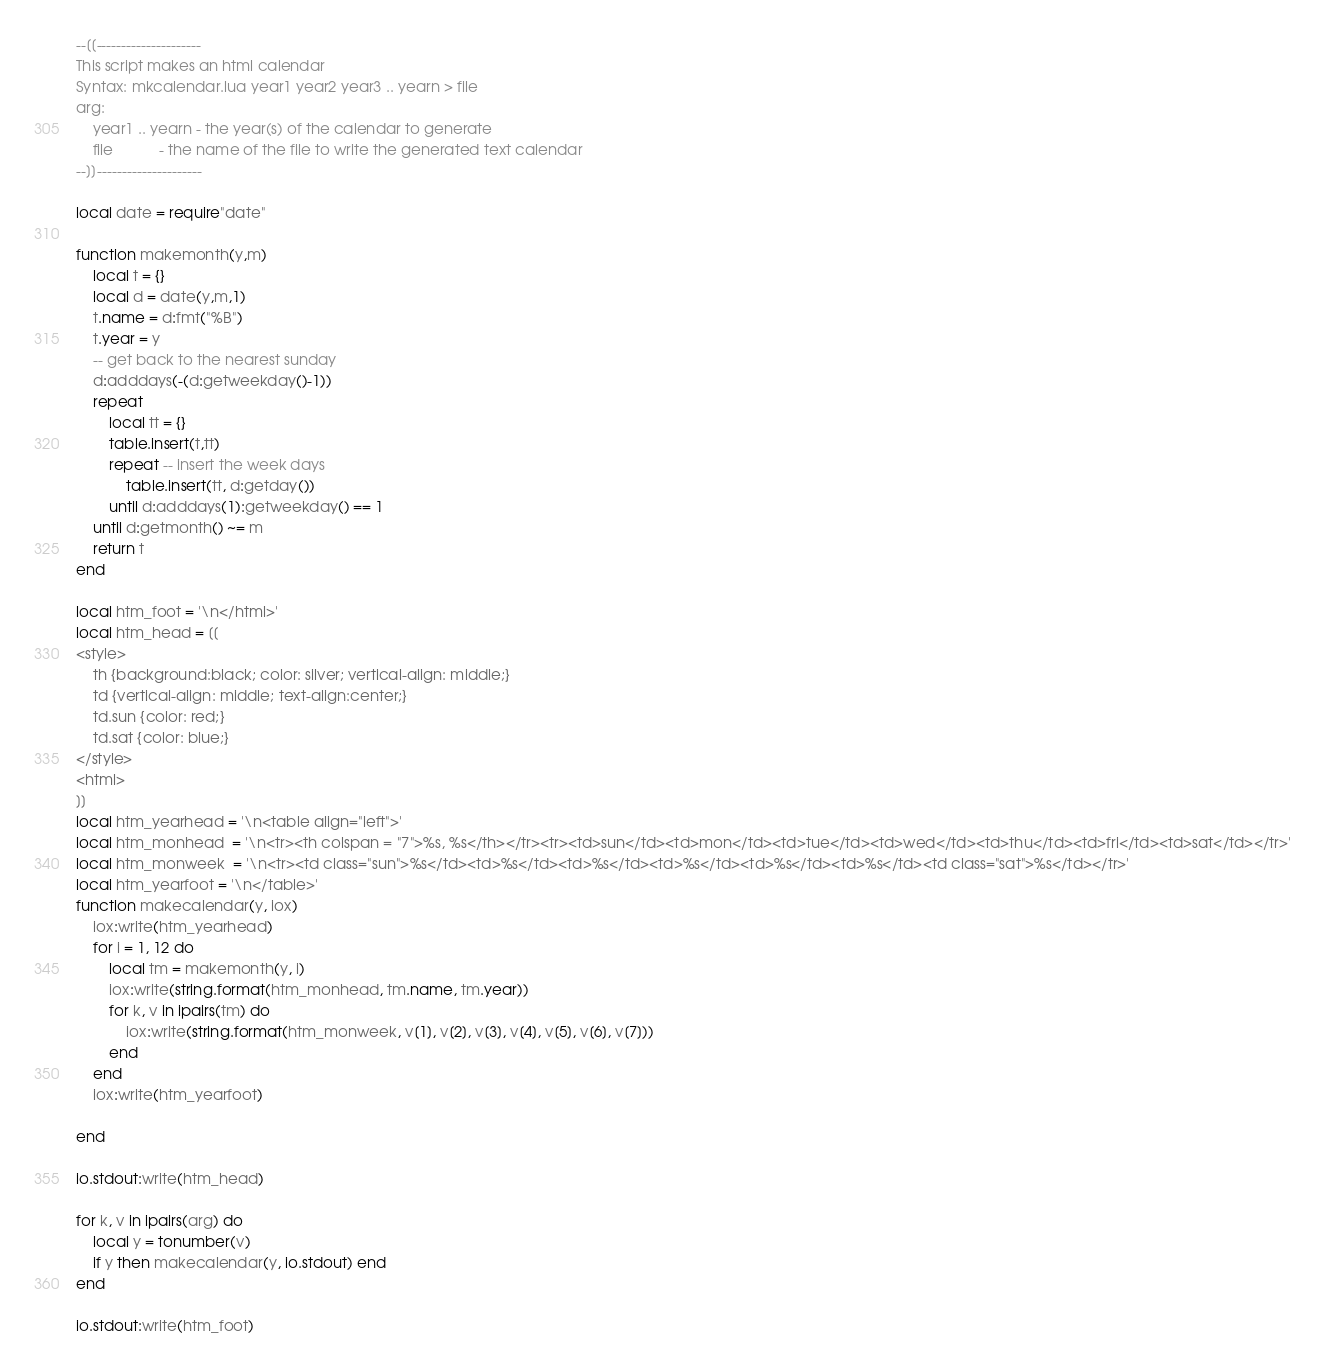<code> <loc_0><loc_0><loc_500><loc_500><_Lua_>--[[---------------------
This script makes an html calendar
Syntax: mkcalendar.lua year1 year2 year3 .. yearn > file
arg:
	year1 .. yearn - the year(s) of the calendar to generate
	file           - the name of the file to write the generated text calendar
--]]---------------------

local date = require"date"

function makemonth(y,m)
	local t = {}
	local d = date(y,m,1)
	t.name = d:fmt("%B")
	t.year = y
	-- get back to the nearest sunday
	d:adddays(-(d:getweekday()-1))
	repeat
		local tt = {}
		table.insert(t,tt)
		repeat -- insert the week days
			table.insert(tt, d:getday())
		until d:adddays(1):getweekday() == 1
	until d:getmonth() ~= m
	return t
end

local htm_foot = '\n</html>'
local htm_head = [[
<style>
	th {background:black; color: silver; vertical-align: middle;}
	td {vertical-align: middle; text-align:center;}
	td.sun {color: red;}
	td.sat {color: blue;}
</style>	
<html>
]]
local htm_yearhead = '\n<table align="left">'
local htm_monhead  = '\n<tr><th colspan = "7">%s, %s</th></tr><tr><td>sun</td><td>mon</td><td>tue</td><td>wed</td><td>thu</td><td>fri</td><td>sat</td></tr>'
local htm_monweek  = '\n<tr><td class="sun">%s</td><td>%s</td><td>%s</td><td>%s</td><td>%s</td><td>%s</td><td class="sat">%s</td></tr>'
local htm_yearfoot = '\n</table>'
function makecalendar(y, iox)
	iox:write(htm_yearhead)	
	for i = 1, 12 do
		local tm = makemonth(y, i)
		iox:write(string.format(htm_monhead, tm.name, tm.year))
		for k, v in ipairs(tm) do
			iox:write(string.format(htm_monweek, v[1], v[2], v[3], v[4], v[5], v[6], v[7]))
		end
	end
	iox:write(htm_yearfoot)
			
end

io.stdout:write(htm_head)

for k, v in ipairs(arg) do
	local y = tonumber(v)
	if y then makecalendar(y, io.stdout) end
end

io.stdout:write(htm_foot)


</code> 